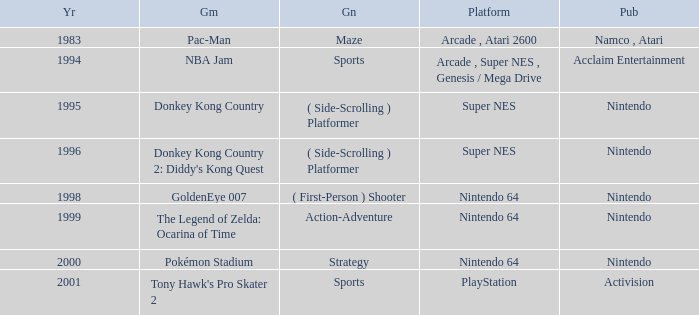Which Genre has a Game of donkey kong country? ( Side-Scrolling ) Platformer. 